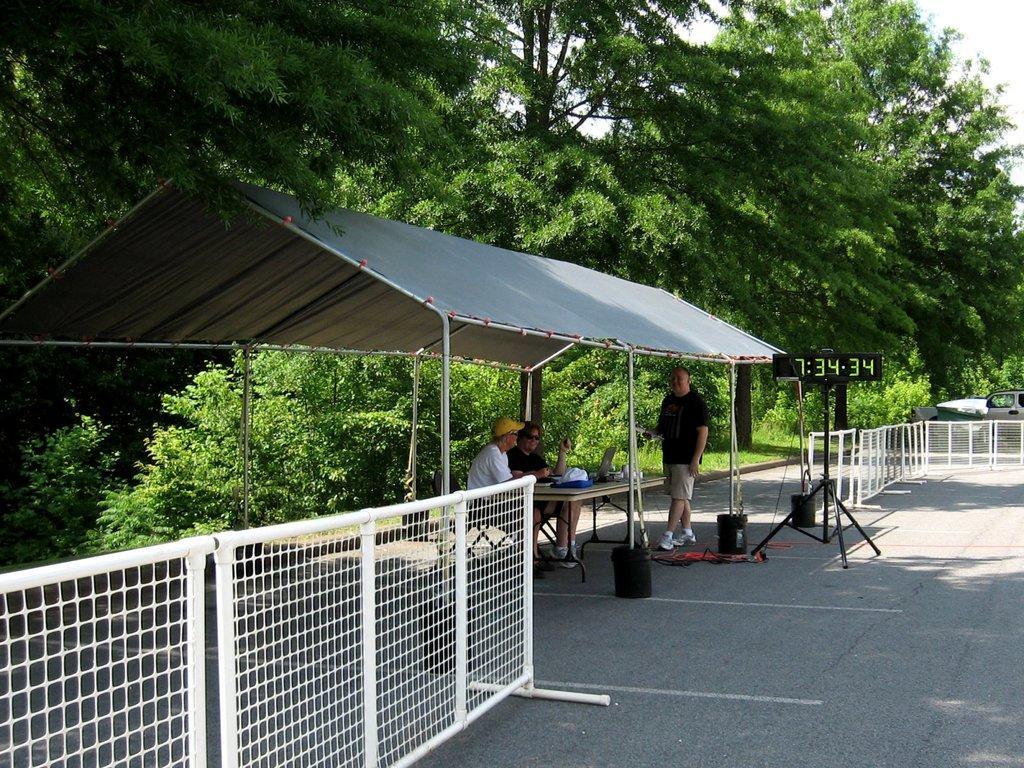How would you summarize this image in a sentence or two? In this picture we can see two men are sitting on the chair. A person is walking and smiling on the path. There are few objects on the table. We can see three black dustbins on the path. There is some fencing from left to right. A device on a tripod is visible on the path. We can see a shed. There are few trees and a car is visible in the background. 